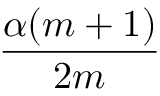<formula> <loc_0><loc_0><loc_500><loc_500>\frac { \alpha ( m + 1 ) } { 2 m }</formula> 